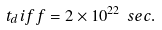Convert formula to latex. <formula><loc_0><loc_0><loc_500><loc_500>t _ { d } i f f = 2 \times 1 0 ^ { 2 2 } \ s e c .</formula> 